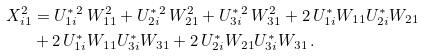<formula> <loc_0><loc_0><loc_500><loc_500>X _ { i 1 } ^ { 2 } & = U ^ { \ast \, 2 } _ { 1 i } \, W _ { 1 1 } ^ { 2 } + U ^ { \ast \, 2 } _ { 2 i } \, W _ { 2 1 } ^ { 2 } + U ^ { \ast \, 2 } _ { 3 i } \, W _ { 3 1 } ^ { 2 } + 2 \, U ^ { \ast } _ { 1 i } W _ { 1 1 } U ^ { \ast } _ { 2 i } W _ { 2 1 } \\ & + 2 \, U ^ { \ast } _ { 1 i } W _ { 1 1 } U ^ { \ast } _ { 3 i } W _ { 3 1 } + 2 \, U ^ { \ast } _ { 2 i } W _ { 2 1 } U ^ { \ast } _ { 3 i } W _ { 3 1 } \, .</formula> 